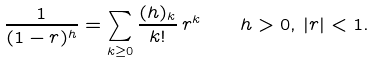Convert formula to latex. <formula><loc_0><loc_0><loc_500><loc_500>\frac { 1 } { ( 1 - r ) ^ { h } } = \sum _ { k \geq 0 } \frac { ( h ) _ { k } } { k ! } \, r ^ { k } \quad h > 0 , \, | r | < 1 .</formula> 